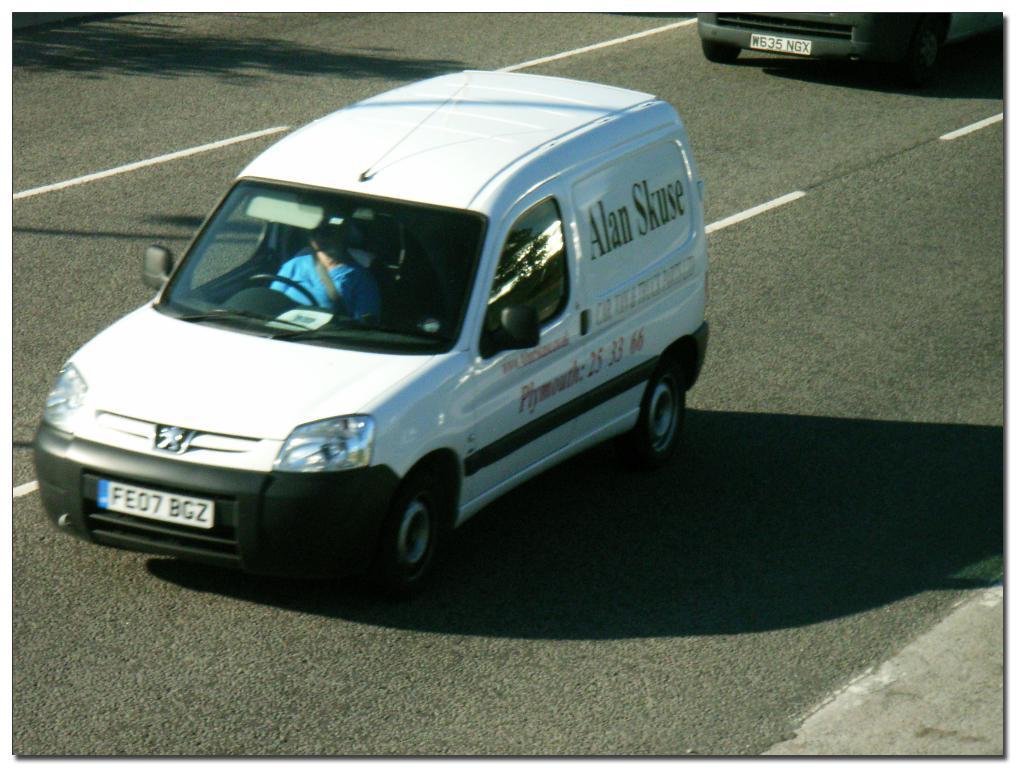Please provide a concise description of this image. In this picture there is a car in the center of the image, which is white in color and there is another car at the top side of the image. 